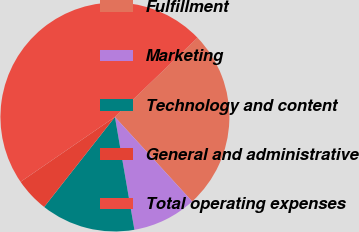<chart> <loc_0><loc_0><loc_500><loc_500><pie_chart><fcel>Fulfillment<fcel>Marketing<fcel>Technology and content<fcel>General and administrative<fcel>Total operating expenses<nl><fcel>25.38%<fcel>9.07%<fcel>13.33%<fcel>4.81%<fcel>47.41%<nl></chart> 